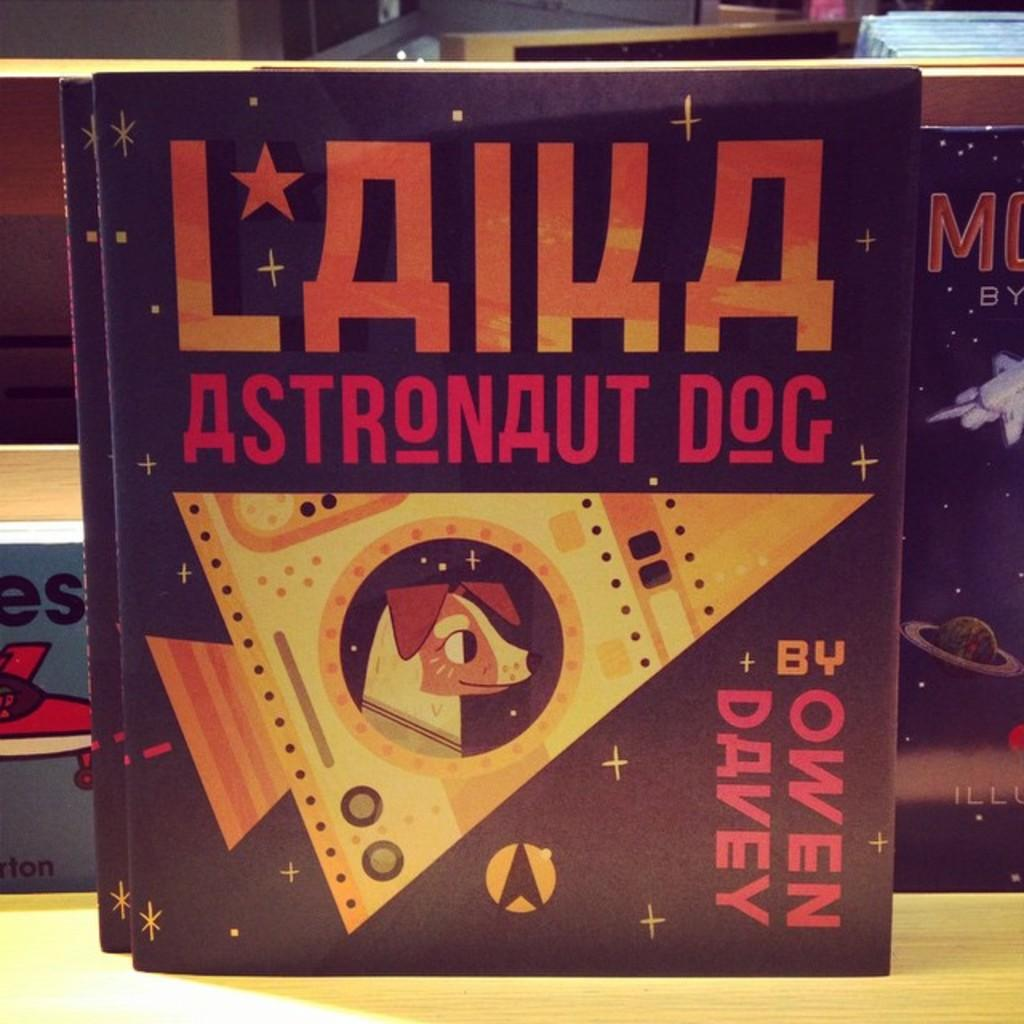<image>
Give a short and clear explanation of the subsequent image. The book Laika Astronaut Dog by Owen Davey on a shelf shows a dog in a space capsule. 